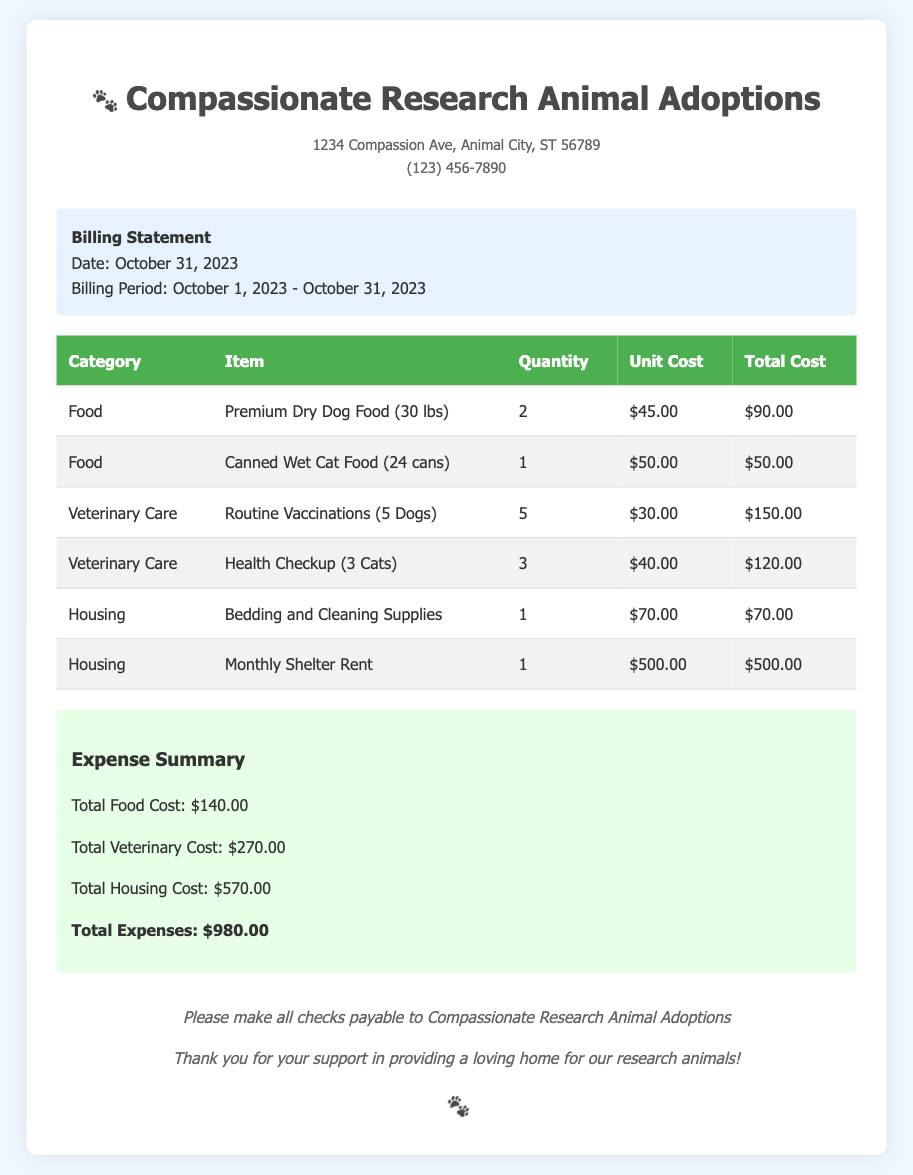What is the billing date? The billing date is stated in the billing information section of the document, which is October 31, 2023.
Answer: October 31, 2023 What is the total cost for food? The total cost for food is calculated by summing the total costs of each food item listed in the table, which comes to $140.00.
Answer: $140.00 How many cans of wet cat food were purchased? The number of cans of wet cat food is specified in the item list under the food category, which shows 24 cans.
Answer: 24 cans What is the total veterinary cost? The total veterinary cost is presented in the expense summary, which sums up to $270.00.
Answer: $270.00 How much does the monthly shelter rent cost? The cost of the monthly shelter rent is listed directly in the housing category of the table, which is $500.00.
Answer: $500.00 What is the total cost for housing? The total cost for housing is provided in the expense summary, calculated from the items listed under housing, amounting to $570.00.
Answer: $570.00 How many dogs received routine vaccinations? The number of dogs receiving routine vaccinations is found in the veterinary care category, which indicates 5 dogs.
Answer: 5 dogs What is the total expense for the month? The total expense for the month is the final total provided in the expense summary, which is $980.00.
Answer: $980.00 What is the address of the organization? The address of the organization is listed at the top of the document, which is 1234 Compassion Ave, Animal City, ST 56789.
Answer: 1234 Compassion Ave, Animal City, ST 56789 